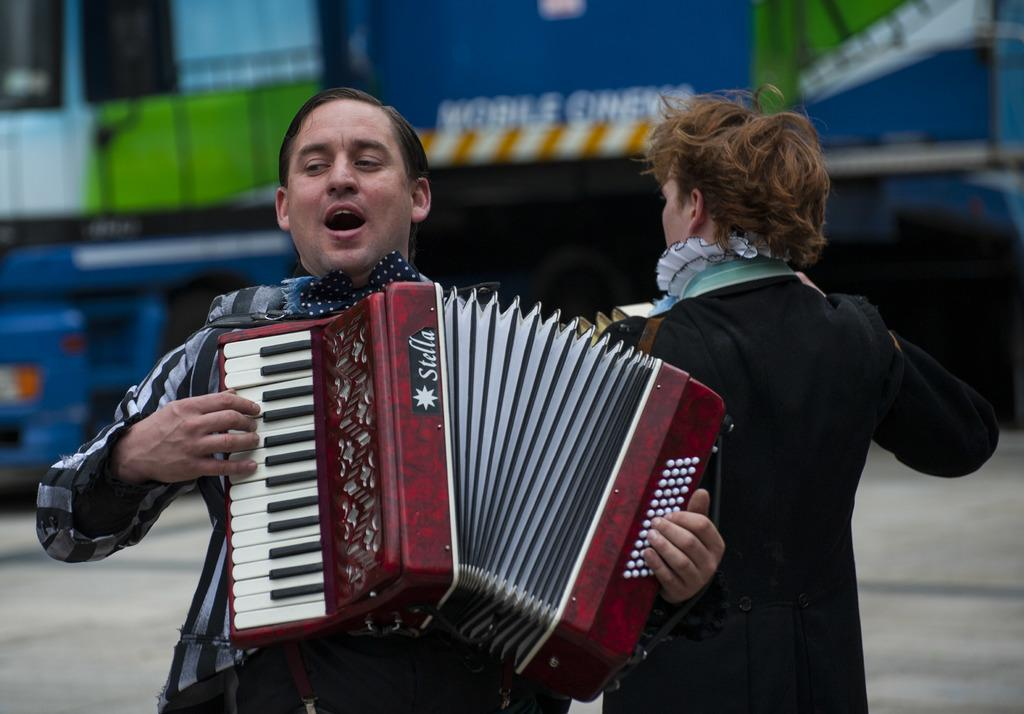Who or what can be seen in the image? There are people in the image. What are the people doing in the image? The people are holding musical instruments. What type of surface is visible in the image? There is ground visible in the image. Where is the nest located in the image? There is no nest present in the image. Can you see a swing in the image? There is no swing present in the image. 